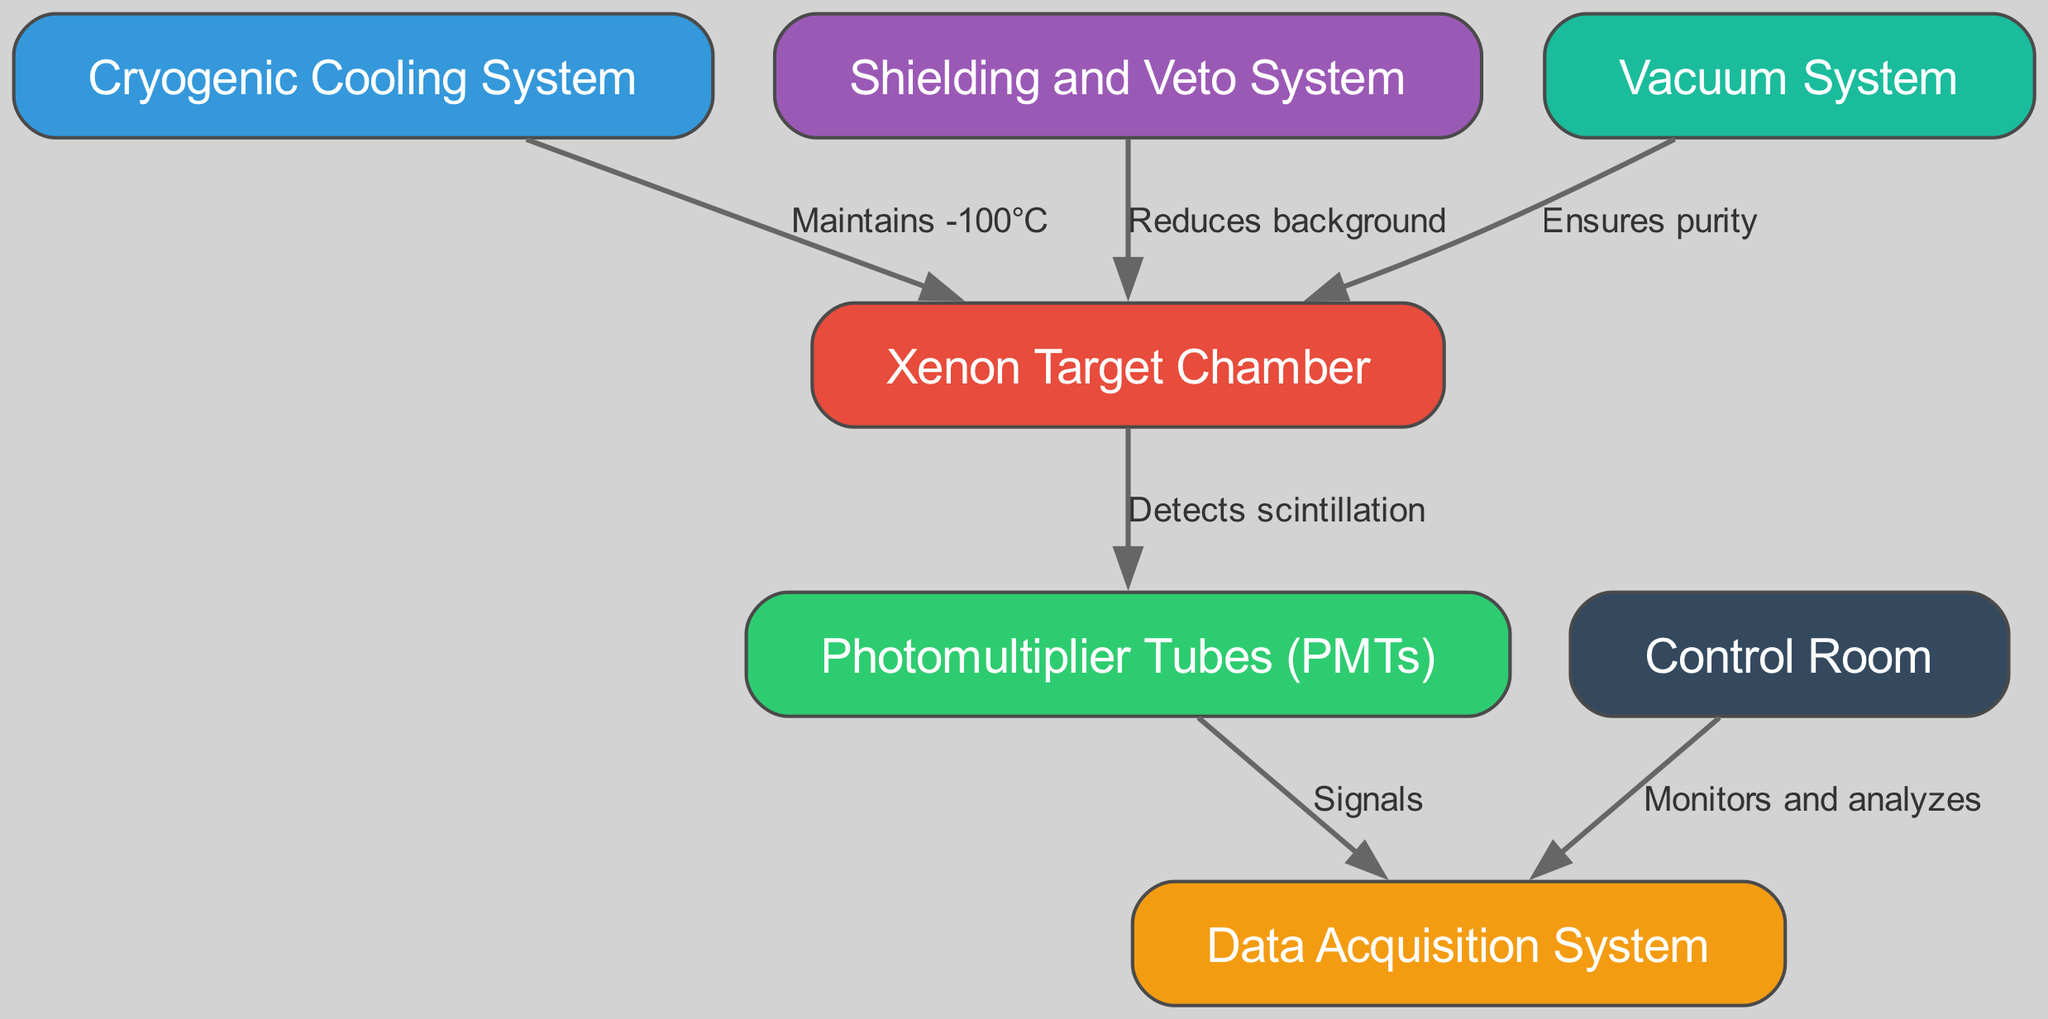What is the role of the Cryogenic Cooling System? The Cryogenic Cooling System is responsible for maintaining a temperature of -100°C, which is essential for the functioning of the Xenon Target Chamber where dark matter interactions may occur.
Answer: Maintains -100°C How many nodes are present in the diagram? The diagram contains a total of 7 nodes, which represent different components of the proposed dark matter detection facility.
Answer: 7 What does the Shielding and Veto System do in relation to the Xenon Target Chamber? The Shielding and Veto System reduces background signals that could interfere with the detection of dark matter interactions in the Xenon Target Chamber.
Answer: Reduces background Which component monitors and analyzes data? The Control Room is the component that monitors and analyzes the signals coming from the Data Acquisition System, providing oversight of the detection process.
Answer: Control Room What is the connection between the Photomultiplier Tubes and the Data Acquisition System? The Photomultiplier Tubes are directly connected to the Data Acquisition System through signals generated when they detect scintillation from the energy interactions in the Xenon Target Chamber.
Answer: Signals What system ensures the purity of the Xenon gas? The Vacuum System is the component that ensures the purity of the Xenon gas within the Xenon Target Chamber, preventing contamination that could affect measurements.
Answer: Ensures purity Which node provides the temperature control for the Xenon Target Chamber? The Cryogenic Cooling System provides the necessary temperature control for the Xenon Target Chamber to maintain optimal conditions for detection.
Answer: Cryogenic Cooling System How does the Vacuum System relate to the Xenon Target Chamber? The Vacuum System maintains the purity of the environment in the Xenon Target Chamber, which is crucial for accurate dark matter detection.
Answer: Ensures purity What type of signals do the Photomultiplier Tubes detect? The Photomultiplier Tubes detect scintillation, which is the light produced when a particle interacts with the Xenon atoms in the chamber.
Answer: Detects scintillation 